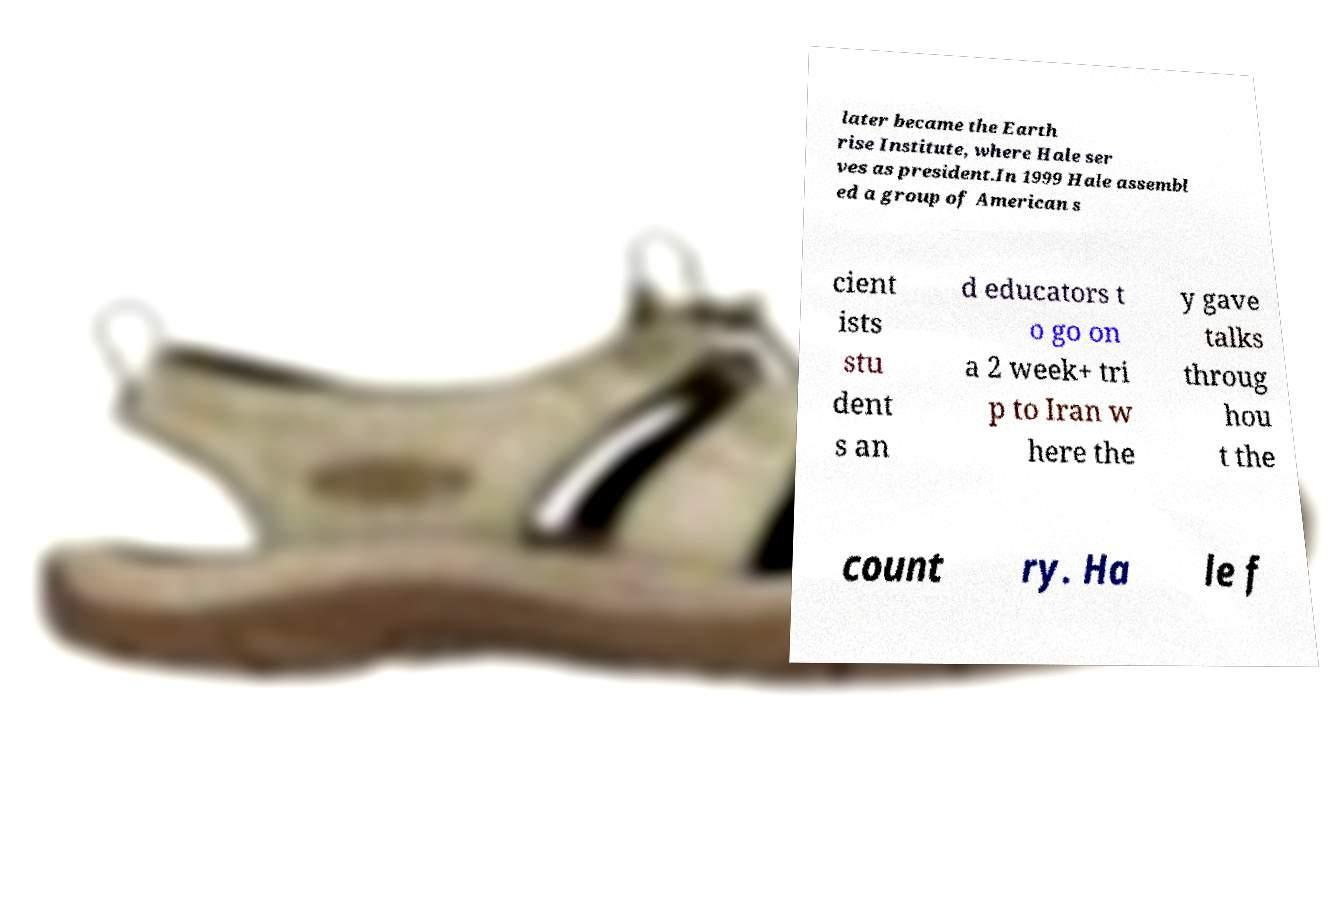What messages or text are displayed in this image? I need them in a readable, typed format. later became the Earth rise Institute, where Hale ser ves as president.In 1999 Hale assembl ed a group of American s cient ists stu dent s an d educators t o go on a 2 week+ tri p to Iran w here the y gave talks throug hou t the count ry. Ha le f 